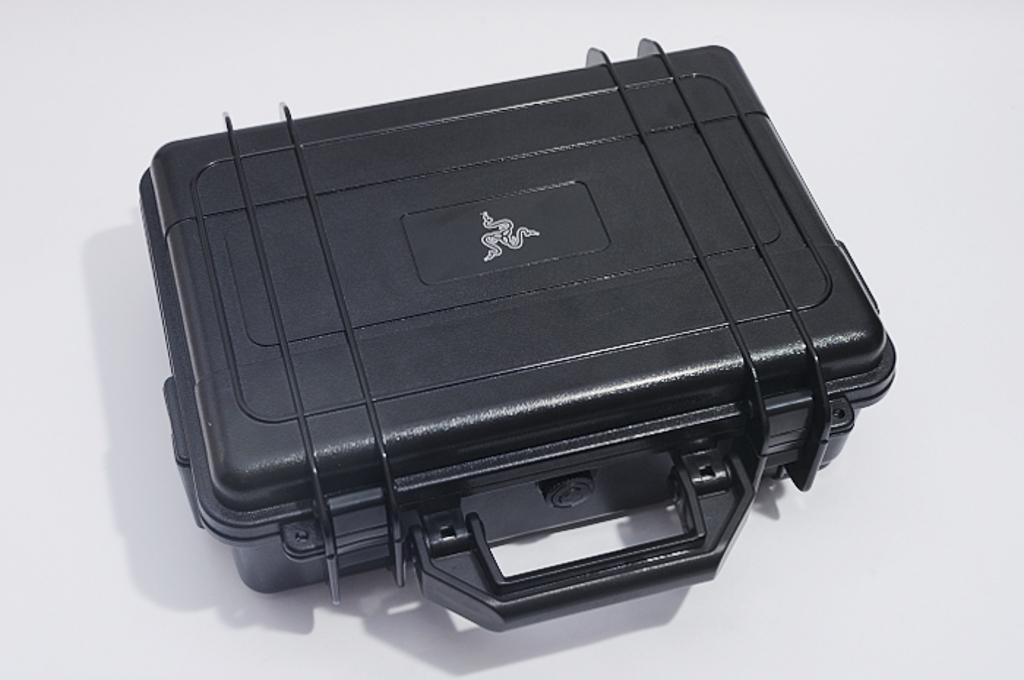What color is the background of the image? The background of the image is white. What object can be seen in the image? There is a black suitcase in the image. What is on the suitcase? There is a white symbol on the suitcase. How many rings are visible on the suitcase in the image? There are no rings visible on the suitcase in the image. 